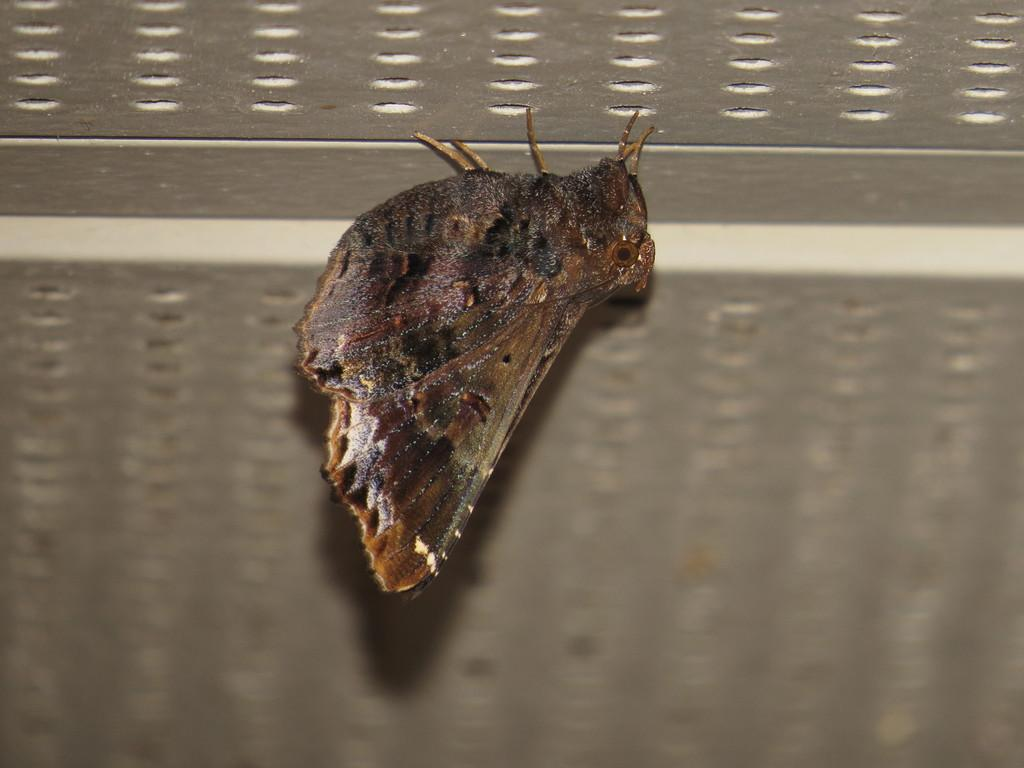What type of creature is present in the image? There is an insect in the image. What color is the insect? The insect is brown in color. What can be seen in the background of the image? There is a silver color surface in the background of the image. What type of zipper is visible on the insect in the image? There is no zipper present on the insect in the image. What type of pan is being used to cook the insect in the image? There is no pan or cooking activity depicted in the image; it only features an insect and a silver color surface in the background. 